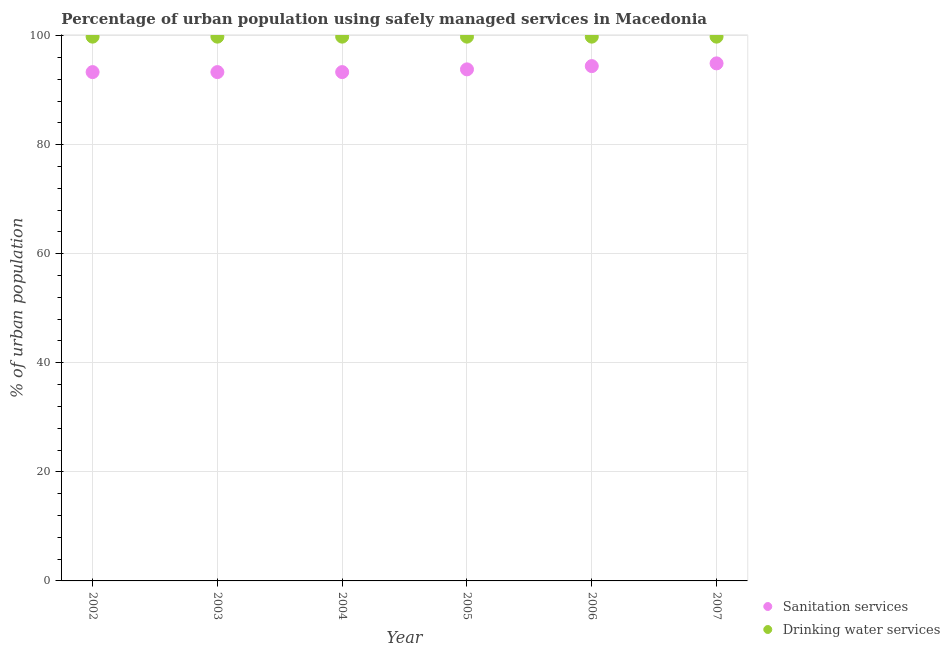What is the percentage of urban population who used sanitation services in 2006?
Your answer should be very brief. 94.4. Across all years, what is the maximum percentage of urban population who used sanitation services?
Keep it short and to the point. 94.9. Across all years, what is the minimum percentage of urban population who used sanitation services?
Give a very brief answer. 93.3. In which year was the percentage of urban population who used drinking water services maximum?
Provide a succinct answer. 2002. What is the total percentage of urban population who used drinking water services in the graph?
Your answer should be compact. 598.8. What is the difference between the percentage of urban population who used sanitation services in 2005 and that in 2007?
Your answer should be compact. -1.1. What is the average percentage of urban population who used sanitation services per year?
Ensure brevity in your answer.  93.83. In the year 2002, what is the difference between the percentage of urban population who used sanitation services and percentage of urban population who used drinking water services?
Provide a succinct answer. -6.5. In how many years, is the percentage of urban population who used sanitation services greater than 56 %?
Your answer should be compact. 6. Is the difference between the percentage of urban population who used drinking water services in 2004 and 2006 greater than the difference between the percentage of urban population who used sanitation services in 2004 and 2006?
Keep it short and to the point. Yes. What is the difference between the highest and the second highest percentage of urban population who used drinking water services?
Keep it short and to the point. 0. What is the difference between the highest and the lowest percentage of urban population who used drinking water services?
Keep it short and to the point. 0. Is the sum of the percentage of urban population who used drinking water services in 2004 and 2005 greater than the maximum percentage of urban population who used sanitation services across all years?
Make the answer very short. Yes. Does the percentage of urban population who used sanitation services monotonically increase over the years?
Your response must be concise. No. Is the percentage of urban population who used sanitation services strictly greater than the percentage of urban population who used drinking water services over the years?
Provide a short and direct response. No. Is the percentage of urban population who used sanitation services strictly less than the percentage of urban population who used drinking water services over the years?
Offer a very short reply. Yes. How many dotlines are there?
Offer a terse response. 2. What is the difference between two consecutive major ticks on the Y-axis?
Give a very brief answer. 20. Does the graph contain any zero values?
Give a very brief answer. No. What is the title of the graph?
Make the answer very short. Percentage of urban population using safely managed services in Macedonia. Does "Number of arrivals" appear as one of the legend labels in the graph?
Your answer should be compact. No. What is the label or title of the X-axis?
Make the answer very short. Year. What is the label or title of the Y-axis?
Provide a short and direct response. % of urban population. What is the % of urban population in Sanitation services in 2002?
Give a very brief answer. 93.3. What is the % of urban population of Drinking water services in 2002?
Ensure brevity in your answer.  99.8. What is the % of urban population of Sanitation services in 2003?
Offer a very short reply. 93.3. What is the % of urban population in Drinking water services in 2003?
Offer a very short reply. 99.8. What is the % of urban population of Sanitation services in 2004?
Your answer should be compact. 93.3. What is the % of urban population in Drinking water services in 2004?
Provide a short and direct response. 99.8. What is the % of urban population of Sanitation services in 2005?
Your answer should be compact. 93.8. What is the % of urban population in Drinking water services in 2005?
Keep it short and to the point. 99.8. What is the % of urban population of Sanitation services in 2006?
Offer a terse response. 94.4. What is the % of urban population of Drinking water services in 2006?
Your response must be concise. 99.8. What is the % of urban population in Sanitation services in 2007?
Your response must be concise. 94.9. What is the % of urban population in Drinking water services in 2007?
Provide a succinct answer. 99.8. Across all years, what is the maximum % of urban population of Sanitation services?
Make the answer very short. 94.9. Across all years, what is the maximum % of urban population of Drinking water services?
Provide a succinct answer. 99.8. Across all years, what is the minimum % of urban population of Sanitation services?
Your answer should be very brief. 93.3. Across all years, what is the minimum % of urban population of Drinking water services?
Offer a very short reply. 99.8. What is the total % of urban population of Sanitation services in the graph?
Your response must be concise. 563. What is the total % of urban population in Drinking water services in the graph?
Offer a terse response. 598.8. What is the difference between the % of urban population in Drinking water services in 2002 and that in 2003?
Keep it short and to the point. 0. What is the difference between the % of urban population in Sanitation services in 2002 and that in 2004?
Offer a terse response. 0. What is the difference between the % of urban population of Drinking water services in 2002 and that in 2005?
Ensure brevity in your answer.  0. What is the difference between the % of urban population in Sanitation services in 2002 and that in 2007?
Keep it short and to the point. -1.6. What is the difference between the % of urban population in Sanitation services in 2003 and that in 2004?
Your answer should be very brief. 0. What is the difference between the % of urban population of Sanitation services in 2003 and that in 2005?
Keep it short and to the point. -0.5. What is the difference between the % of urban population of Drinking water services in 2003 and that in 2005?
Give a very brief answer. 0. What is the difference between the % of urban population of Sanitation services in 2003 and that in 2007?
Offer a very short reply. -1.6. What is the difference between the % of urban population of Sanitation services in 2004 and that in 2006?
Your answer should be very brief. -1.1. What is the difference between the % of urban population in Drinking water services in 2004 and that in 2006?
Your answer should be very brief. 0. What is the difference between the % of urban population in Sanitation services in 2004 and that in 2007?
Provide a short and direct response. -1.6. What is the difference between the % of urban population in Sanitation services in 2005 and that in 2006?
Your answer should be very brief. -0.6. What is the difference between the % of urban population in Drinking water services in 2005 and that in 2006?
Provide a succinct answer. 0. What is the difference between the % of urban population of Sanitation services in 2006 and that in 2007?
Give a very brief answer. -0.5. What is the difference between the % of urban population of Sanitation services in 2002 and the % of urban population of Drinking water services in 2003?
Ensure brevity in your answer.  -6.5. What is the difference between the % of urban population in Sanitation services in 2002 and the % of urban population in Drinking water services in 2004?
Offer a very short reply. -6.5. What is the difference between the % of urban population in Sanitation services in 2002 and the % of urban population in Drinking water services in 2005?
Provide a short and direct response. -6.5. What is the difference between the % of urban population of Sanitation services in 2003 and the % of urban population of Drinking water services in 2006?
Your answer should be compact. -6.5. What is the difference between the % of urban population of Sanitation services in 2005 and the % of urban population of Drinking water services in 2007?
Make the answer very short. -6. What is the average % of urban population of Sanitation services per year?
Keep it short and to the point. 93.83. What is the average % of urban population in Drinking water services per year?
Give a very brief answer. 99.8. In the year 2002, what is the difference between the % of urban population of Sanitation services and % of urban population of Drinking water services?
Make the answer very short. -6.5. In the year 2005, what is the difference between the % of urban population in Sanitation services and % of urban population in Drinking water services?
Your response must be concise. -6. In the year 2006, what is the difference between the % of urban population of Sanitation services and % of urban population of Drinking water services?
Provide a succinct answer. -5.4. In the year 2007, what is the difference between the % of urban population in Sanitation services and % of urban population in Drinking water services?
Ensure brevity in your answer.  -4.9. What is the ratio of the % of urban population in Sanitation services in 2002 to that in 2003?
Make the answer very short. 1. What is the ratio of the % of urban population of Sanitation services in 2002 to that in 2004?
Give a very brief answer. 1. What is the ratio of the % of urban population in Sanitation services in 2002 to that in 2005?
Provide a short and direct response. 0.99. What is the ratio of the % of urban population in Drinking water services in 2002 to that in 2005?
Keep it short and to the point. 1. What is the ratio of the % of urban population of Sanitation services in 2002 to that in 2006?
Provide a succinct answer. 0.99. What is the ratio of the % of urban population in Sanitation services in 2002 to that in 2007?
Ensure brevity in your answer.  0.98. What is the ratio of the % of urban population of Drinking water services in 2002 to that in 2007?
Ensure brevity in your answer.  1. What is the ratio of the % of urban population of Drinking water services in 2003 to that in 2004?
Your answer should be very brief. 1. What is the ratio of the % of urban population of Sanitation services in 2003 to that in 2005?
Ensure brevity in your answer.  0.99. What is the ratio of the % of urban population in Drinking water services in 2003 to that in 2005?
Ensure brevity in your answer.  1. What is the ratio of the % of urban population in Sanitation services in 2003 to that in 2006?
Make the answer very short. 0.99. What is the ratio of the % of urban population in Drinking water services in 2003 to that in 2006?
Ensure brevity in your answer.  1. What is the ratio of the % of urban population of Sanitation services in 2003 to that in 2007?
Make the answer very short. 0.98. What is the ratio of the % of urban population in Drinking water services in 2003 to that in 2007?
Your answer should be compact. 1. What is the ratio of the % of urban population of Sanitation services in 2004 to that in 2005?
Your response must be concise. 0.99. What is the ratio of the % of urban population in Sanitation services in 2004 to that in 2006?
Offer a terse response. 0.99. What is the ratio of the % of urban population of Sanitation services in 2004 to that in 2007?
Make the answer very short. 0.98. What is the ratio of the % of urban population of Sanitation services in 2005 to that in 2007?
Ensure brevity in your answer.  0.99. What is the difference between the highest and the second highest % of urban population in Sanitation services?
Offer a terse response. 0.5. What is the difference between the highest and the lowest % of urban population of Sanitation services?
Offer a very short reply. 1.6. 